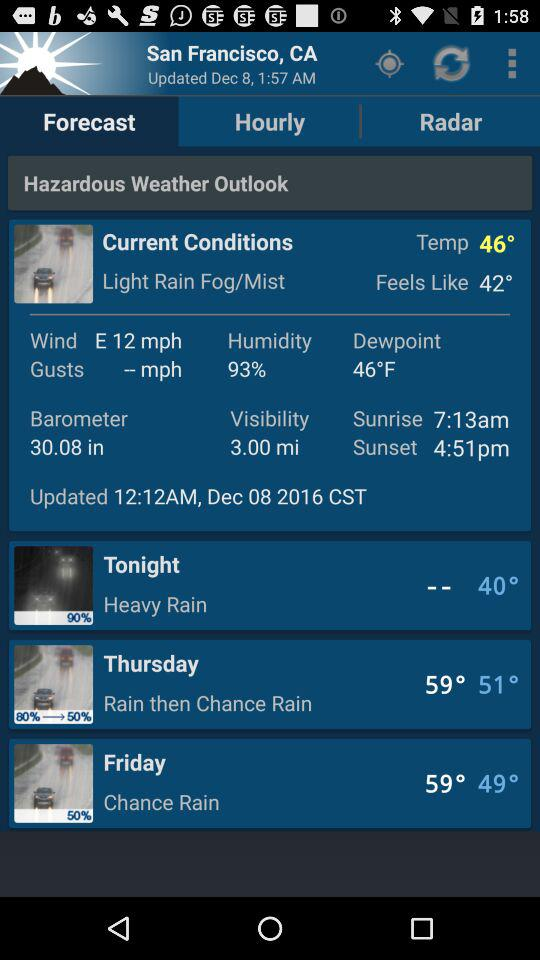How much is the humidity? The humidity is 93%. 